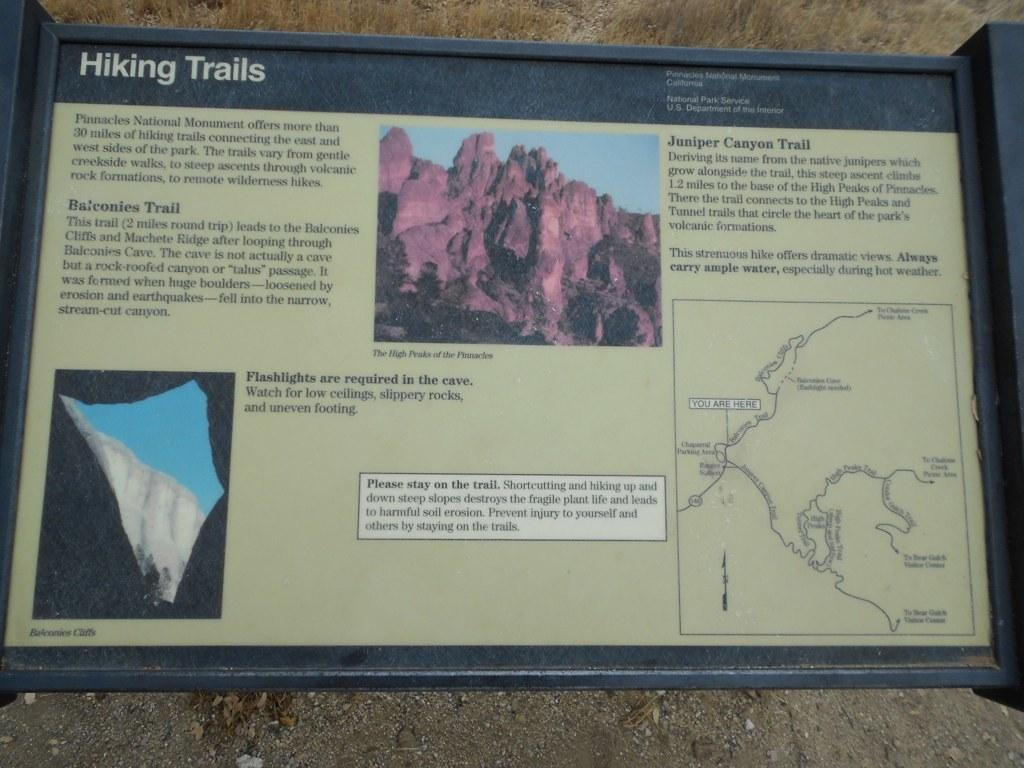Provide a one-sentence caption for the provided image. An outdoor informational display for hiking trails at Juniper Canyon. 